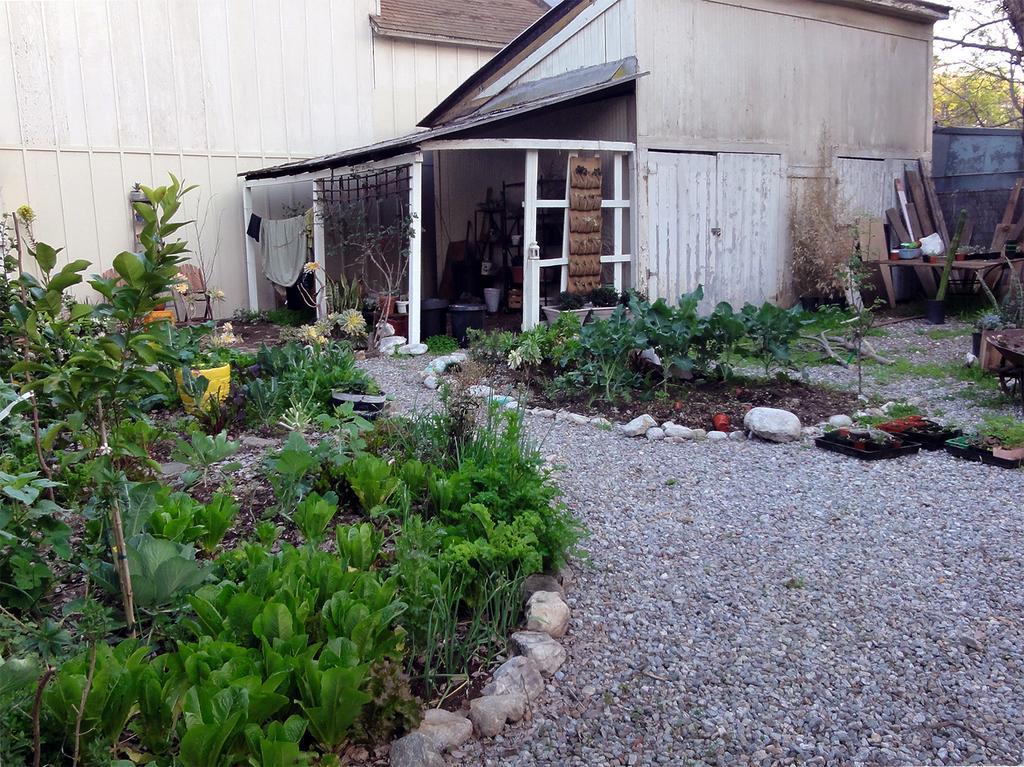Please provide a concise description of this image. At the bottom of the image on the ground there are small stones. And also there are small plants with leaves. Around the plants there are stones. In the background there is a room with roofs, poles, walls, roofs and rope with clothes. On the right corner of the image there are wooden pieces. Behind them there is wall. Behind the wall there are trees. And in the background there is wall. 